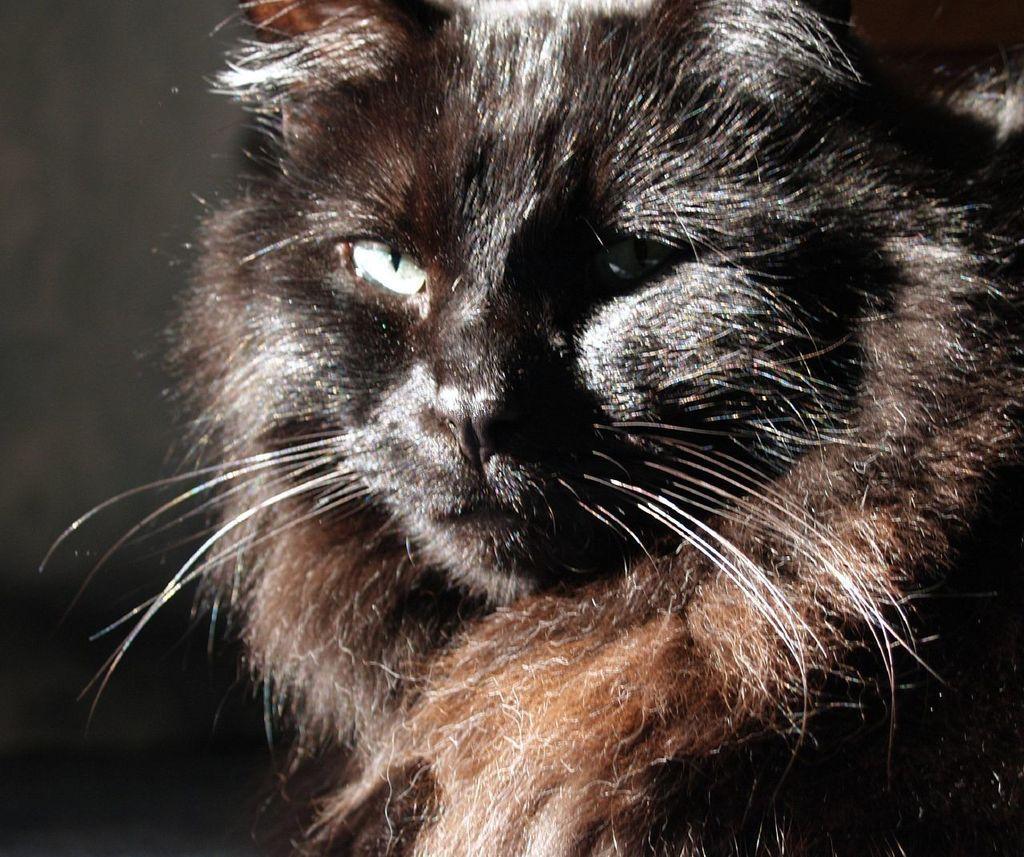Describe this image in one or two sentences. In this picture there is a black color cat. 